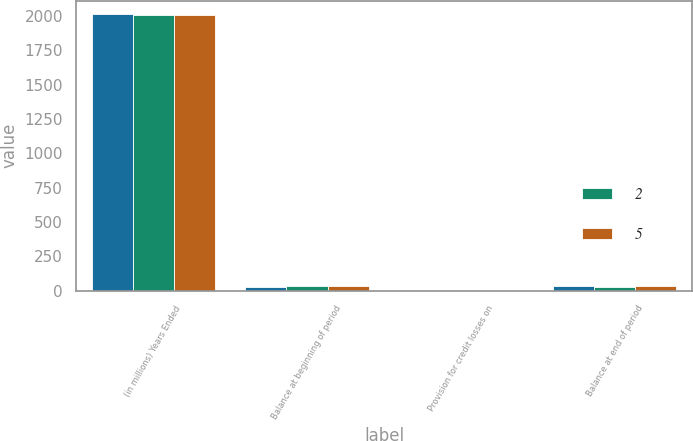<chart> <loc_0><loc_0><loc_500><loc_500><stacked_bar_chart><ecel><fcel>(in millions) Years Ended<fcel>Balance at beginning of period<fcel>Provision for credit losses on<fcel>Balance at end of period<nl><fcel>nan<fcel>2012<fcel>26<fcel>6<fcel>32<nl><fcel>2<fcel>2011<fcel>35<fcel>9<fcel>26<nl><fcel>5<fcel>2010<fcel>37<fcel>2<fcel>35<nl></chart> 